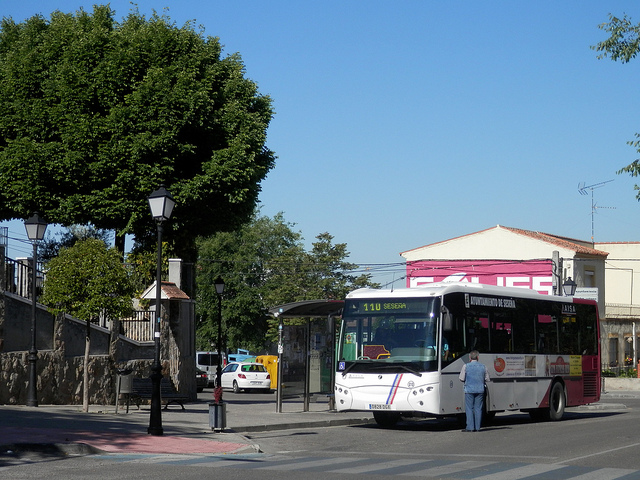Identify the text displayed in this image. 11U LISL 